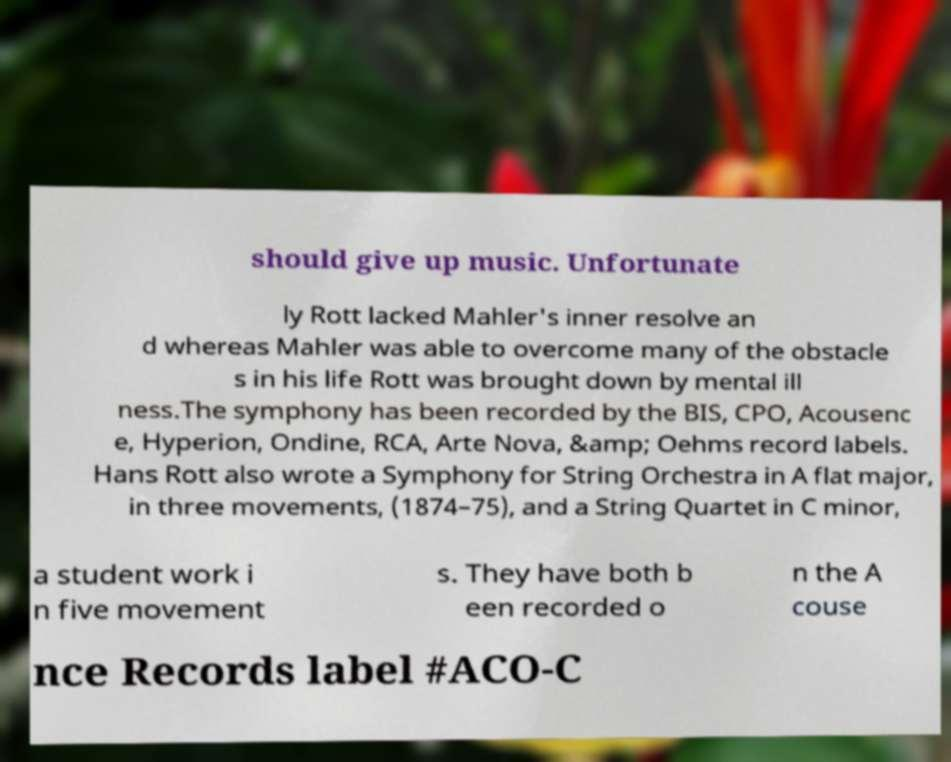I need the written content from this picture converted into text. Can you do that? should give up music. Unfortunate ly Rott lacked Mahler's inner resolve an d whereas Mahler was able to overcome many of the obstacle s in his life Rott was brought down by mental ill ness.The symphony has been recorded by the BIS, CPO, Acousenc e, Hyperion, Ondine, RCA, Arte Nova, &amp; Oehms record labels. Hans Rott also wrote a Symphony for String Orchestra in A flat major, in three movements, (1874–75), and a String Quartet in C minor, a student work i n five movement s. They have both b een recorded o n the A couse nce Records label #ACO-C 